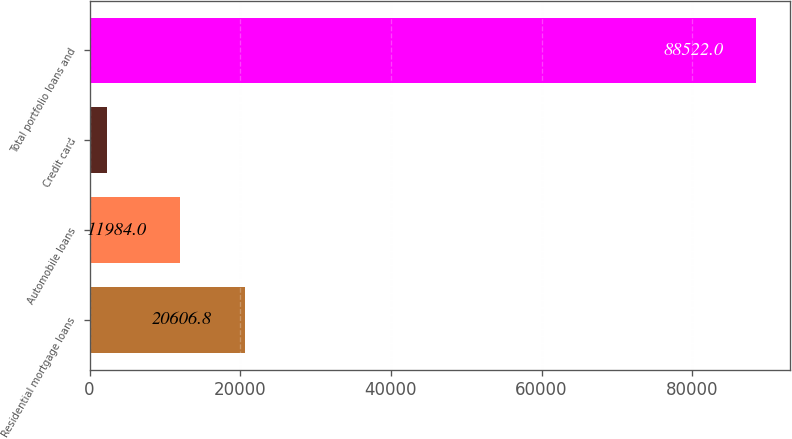<chart> <loc_0><loc_0><loc_500><loc_500><bar_chart><fcel>Residential mortgage loans<fcel>Automobile loans<fcel>Credit card<fcel>Total portfolio loans and<nl><fcel>20606.8<fcel>11984<fcel>2294<fcel>88522<nl></chart> 